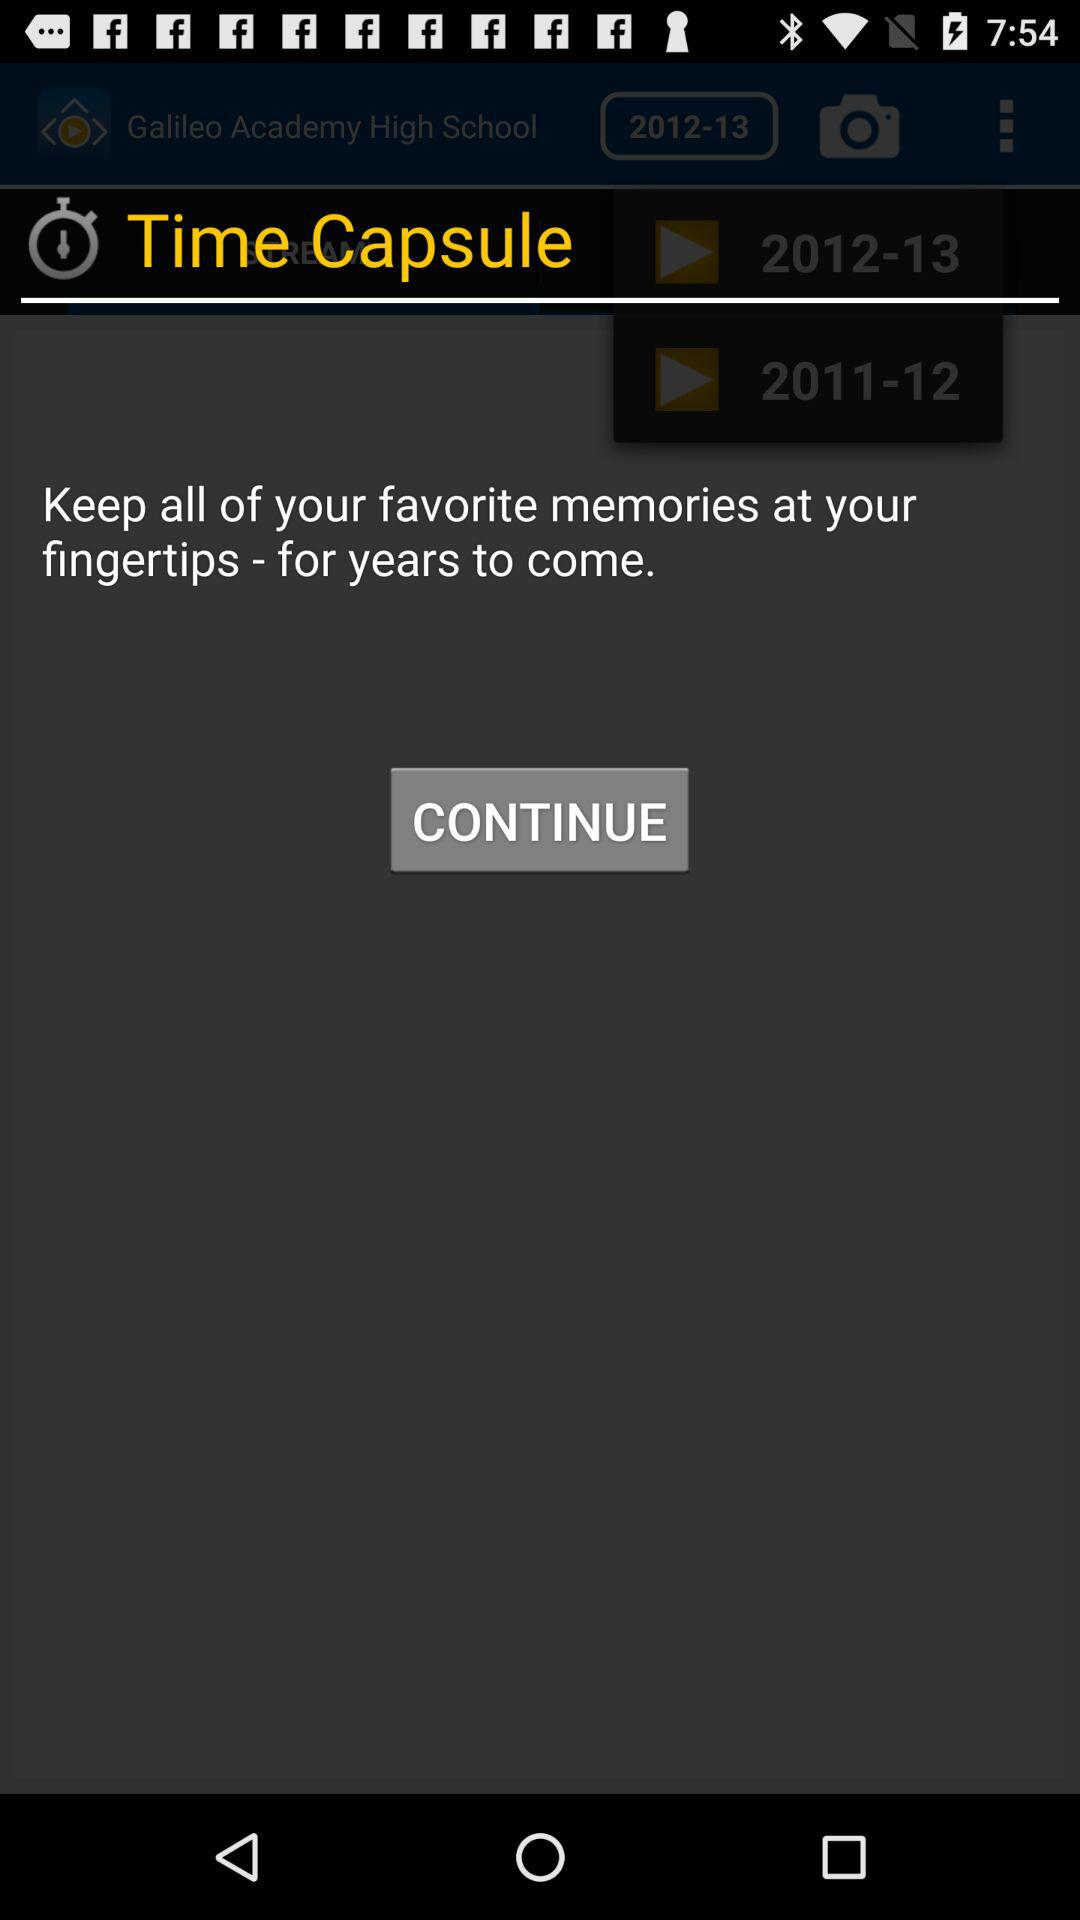How many years are available to choose from?
Answer the question using a single word or phrase. 2 